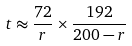Convert formula to latex. <formula><loc_0><loc_0><loc_500><loc_500>t \approx \frac { 7 2 } { r } \times \frac { 1 9 2 } { 2 0 0 - r }</formula> 